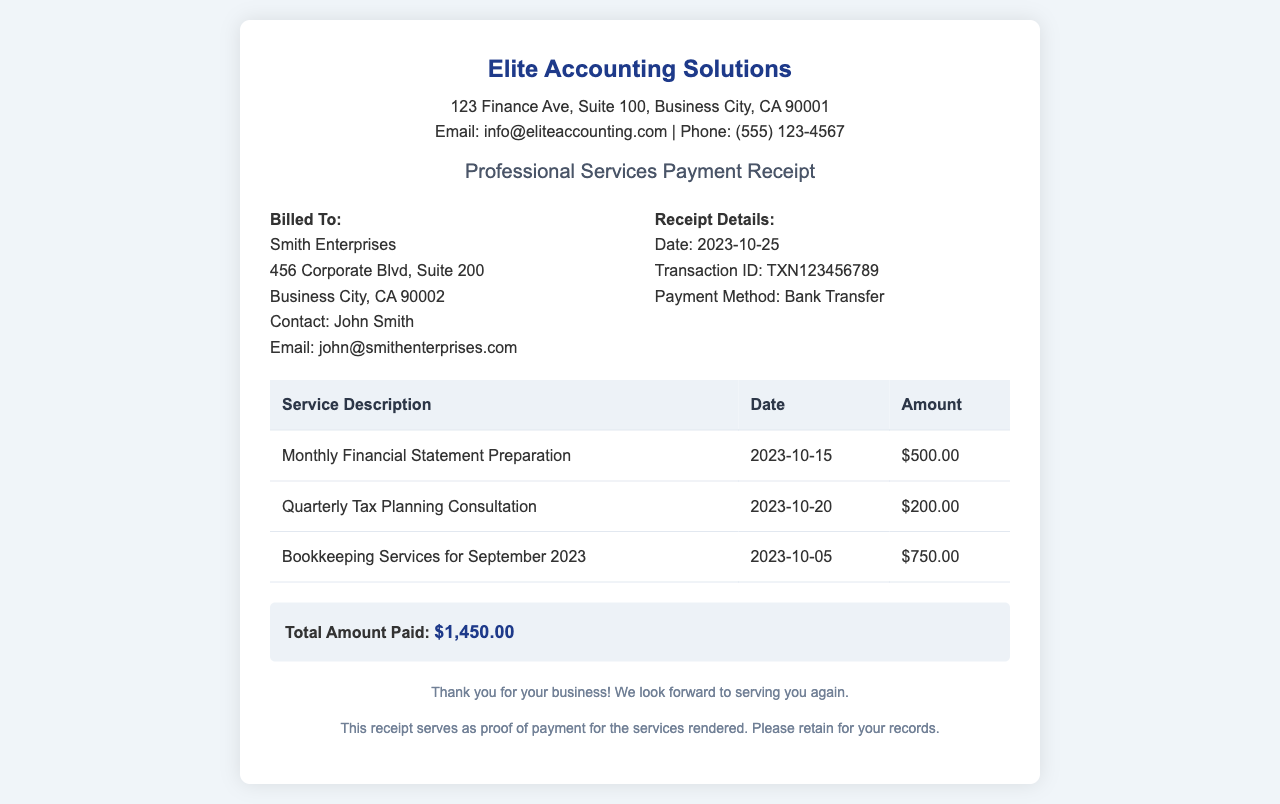What is the company name on the receipt? The company name is prominently displayed at the top of the receipt.
Answer: Elite Accounting Solutions What is the date of the receipt? The date of the receipt is provided under the receipt details section.
Answer: 2023-10-25 What is the payment method used? The payment method is listed in the receipt details section.
Answer: Bank Transfer How much was charged for the Monthly Financial Statement Preparation? The amount charged for this service is provided in the service table.
Answer: $500.00 What company was billed for the services? The company that was billed is identified in the billed to section.
Answer: Smith Enterprises What is the total amount paid? The total amount paid is summarized at the bottom of the receipt.
Answer: $1,450.00 How many services were rendered in total? The number of services rendered can be counted from the service table rows.
Answer: 3 What is the transaction ID? The transaction ID is specified in the receipt details section.
Answer: TXN123456789 Who is the contact person for the billed company? The receipt mentions a contact person for clarity.
Answer: John Smith 